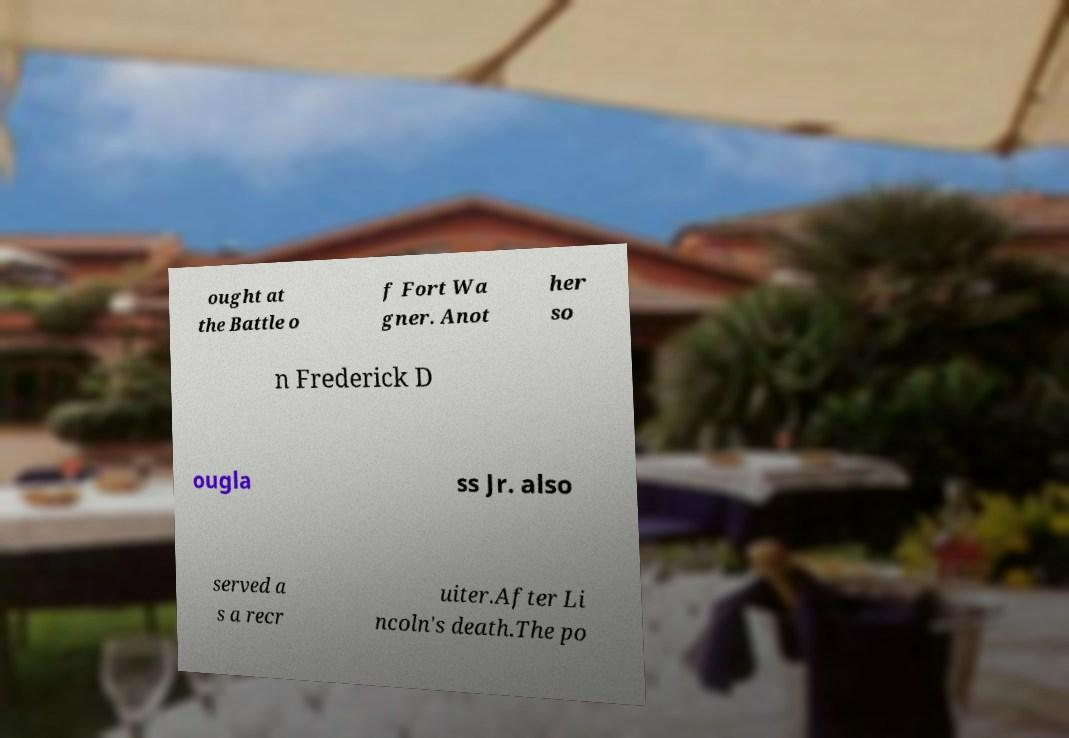Please read and relay the text visible in this image. What does it say? ought at the Battle o f Fort Wa gner. Anot her so n Frederick D ougla ss Jr. also served a s a recr uiter.After Li ncoln's death.The po 